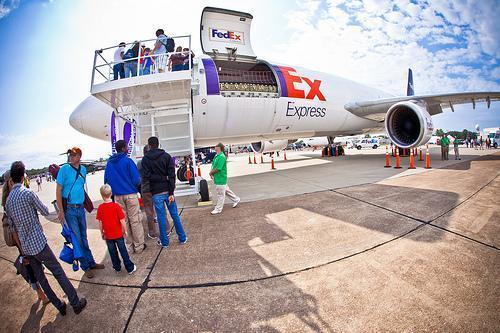How many kids are waiting in the line?
Give a very brief answer. 1. 